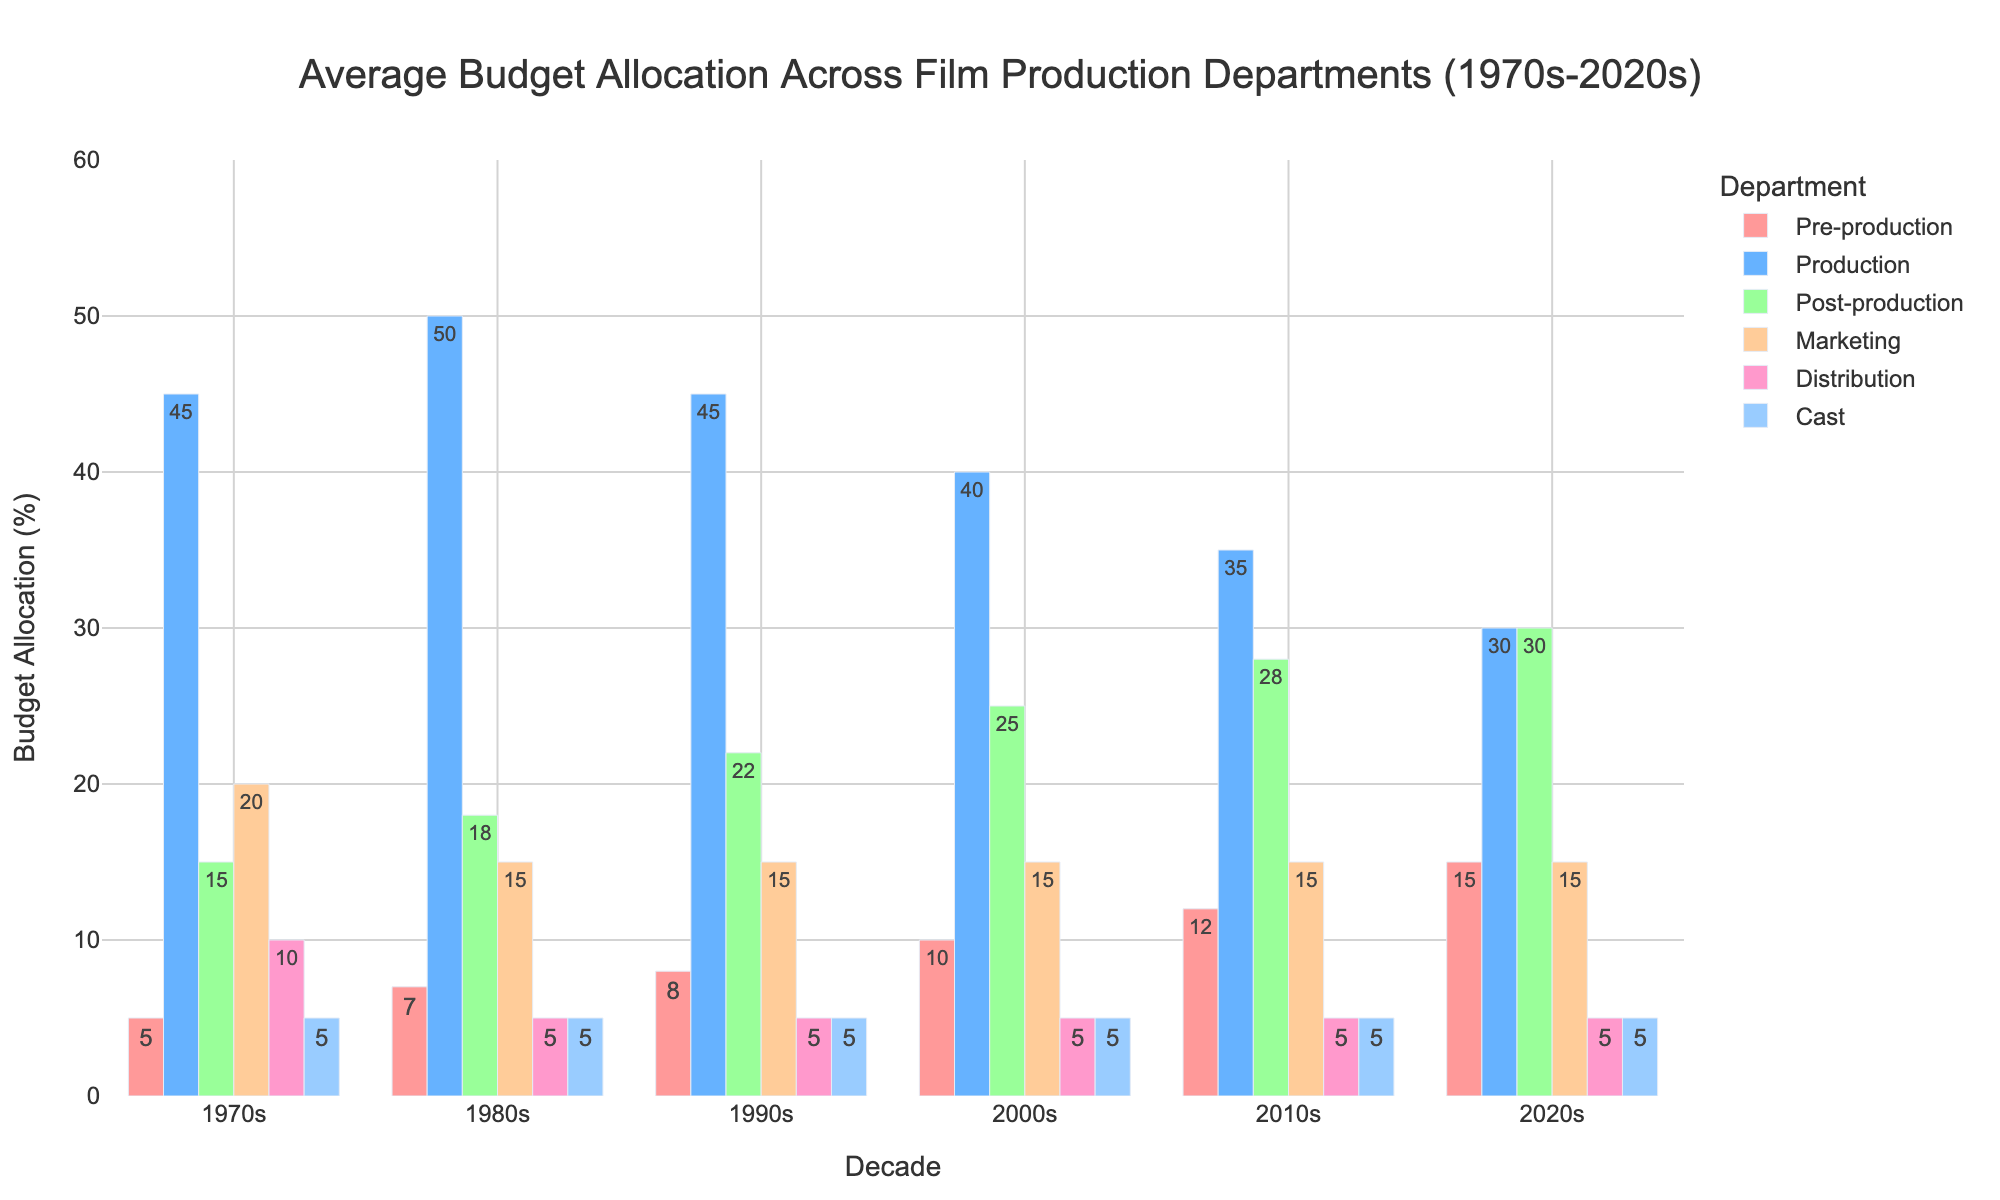What department saw the most significant increase in budget allocation from the 1970s to the 2020s? Look at the budget allocation in the 1970s and compare it to the allocation in the 2020s for each department. Pre-production increased from 5% to 15%, a difference of 10 percentage points. Production decreased, post-production increased by 15 percentage points, marketing remained the same, distribution decreased, and the cast remained the same. So, post-production had the most significant increase.
Answer: Post-production Which department's budget allocation remained constant from the 1970s to the 2020s? For each department, compare the budget allocation in the 1970s to the allocation in the 2020s. Only the Cast department remained the same at 5% throughout the decades.
Answer: Cast How did the budget allocation for production change over the decades? Examine the percentage allocation for the production department across each decade: 1970s (45%), 1980s (50%), 1990s (45%), 2000s (40%), 2010s (35%), 2020s (30%). There is a general declining trend in the budget allocation.
Answer: Decreasing Which departments have an equal budget allocation in the 2020s? Compare the budget allocation percentages in the 2020s across all departments. The post-production and production departments both have 30%, while the marketing, distribution, and cast departments each have 5%.
Answer: Post-production and Production; Marketing, Distribution, and Cast By how much did the budget for distribution decrease from the 1970s to the 1980s? Look at the percentage allocation for the distribution department in both the 1970s (10%) and the 1980s (5%). The difference is 10% - 5% = 5%.
Answer: 5% Which decade saw the highest allocation for the production department? Check the budget allocation for the production department across all decades: 1970s (45%), 1980s (50%), 1990s (45%), 2000s (40%), 2010s (35%), 2020s (30%). The 1980s had the highest allocation at 50%.
Answer: 1980s How much did the budget allocation for pre-production increase from the 2000s to the 2020s? Compare the allocation in the 2000s (10%) to the 2020s (15%) for pre-production. The increase is 15% - 10% = 5%.
Answer: 5% What trend can be observed in the marketing department’s budget allocation over the decades? Examine the budget allocation for the marketing department across each decade: 1970s (20%), 1980s (15%), 1990s (15%), 2000s (15%), 2010s (15%), 2020s (15%). There was a drop from 20% to 15% between the 1970s and 1980s, after which it stabilized.
Answer: Initial decrease and then stable What’s the average budget allocation for post-production over the decades? Sum up the budget allocation percentages for each decade for post-production (15% + 18% + 22% + 25% + 28% + 30%) and then divide by 6 (number of decades). The total is 138%, and the average is 138% / 6 = 23%.
Answer: 23% 